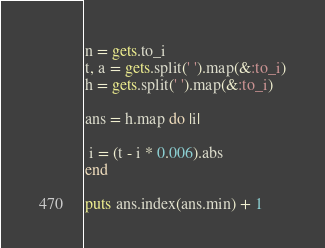Convert code to text. <code><loc_0><loc_0><loc_500><loc_500><_Ruby_>n = gets.to_i
t, a = gets.split(' ').map(&:to_i)
h = gets.split(' ').map(&:to_i)

ans = h.map do |i|

 i = (t - i * 0.006).abs
end

puts ans.index(ans.min) + 1</code> 